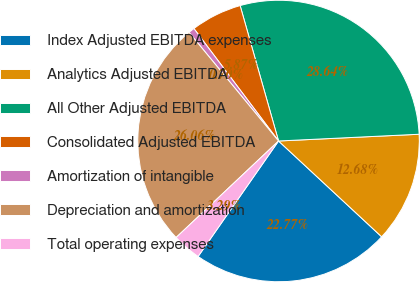<chart> <loc_0><loc_0><loc_500><loc_500><pie_chart><fcel>Index Adjusted EBITDA expenses<fcel>Analytics Adjusted EBITDA<fcel>All Other Adjusted EBITDA<fcel>Consolidated Adjusted EBITDA<fcel>Amortization of intangible<fcel>Depreciation and amortization<fcel>Total operating expenses<nl><fcel>22.77%<fcel>12.68%<fcel>28.64%<fcel>5.87%<fcel>0.7%<fcel>26.06%<fcel>3.29%<nl></chart> 